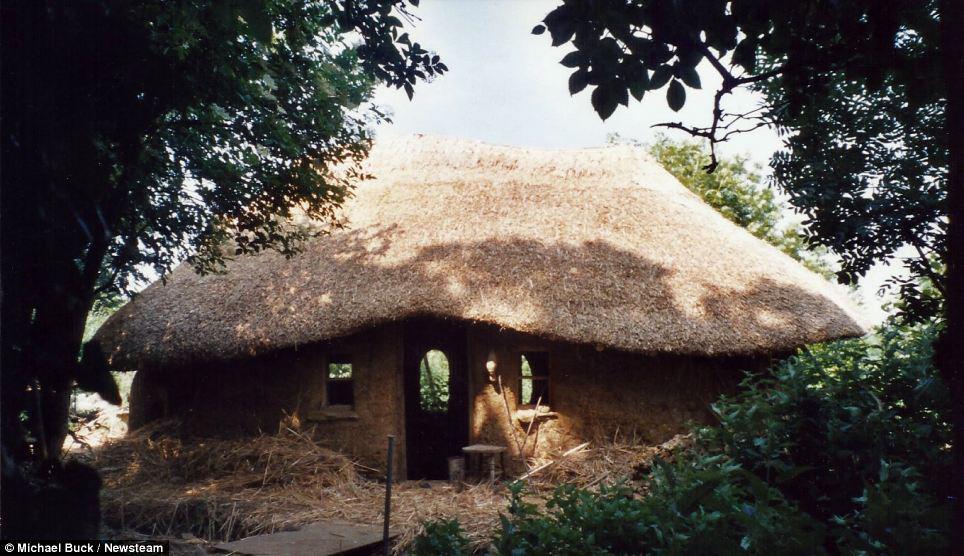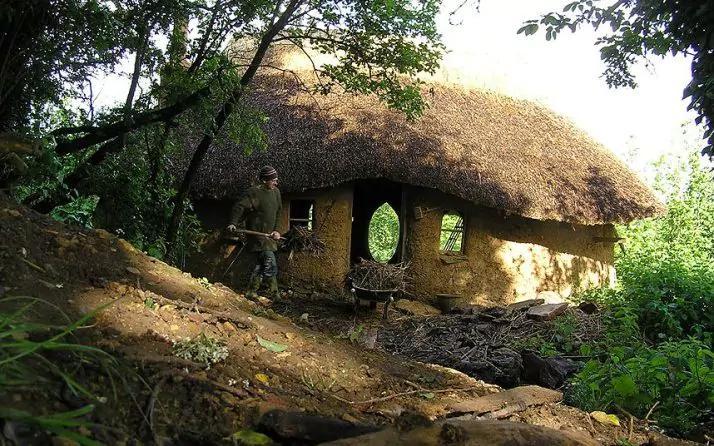The first image is the image on the left, the second image is the image on the right. For the images shown, is this caption "In at least one of the images you can see all the way through the house to the outside." true? Answer yes or no. Yes. 